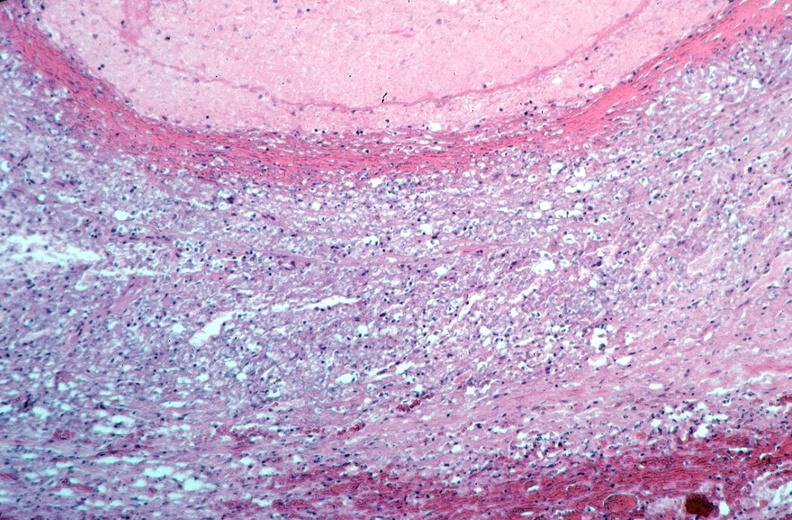where is this from?
Answer the question using a single word or phrase. Vasculature 